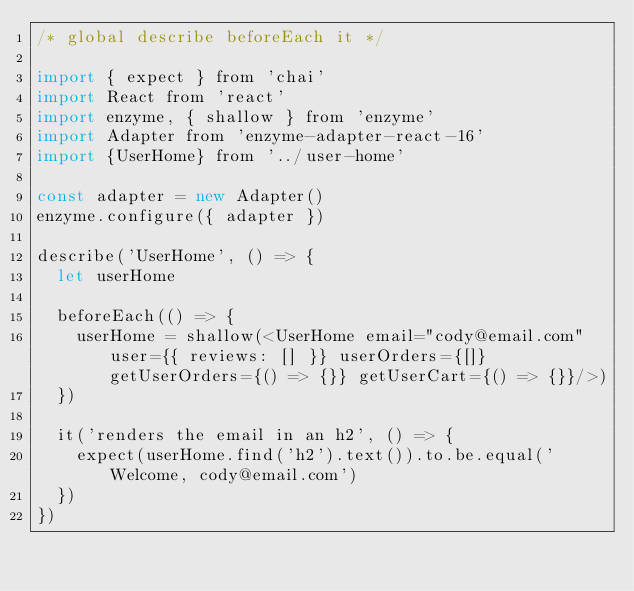Convert code to text. <code><loc_0><loc_0><loc_500><loc_500><_JavaScript_>/* global describe beforeEach it */

import { expect } from 'chai'
import React from 'react'
import enzyme, { shallow } from 'enzyme'
import Adapter from 'enzyme-adapter-react-16'
import {UserHome} from '../user-home'

const adapter = new Adapter()
enzyme.configure({ adapter })

describe('UserHome', () => {
  let userHome

  beforeEach(() => {
    userHome = shallow(<UserHome email="cody@email.com" user={{ reviews: [] }} userOrders={[]} getUserOrders={() => {}} getUserCart={() => {}}/>)
  })

  it('renders the email in an h2', () => {
    expect(userHome.find('h2').text()).to.be.equal('Welcome, cody@email.com')
  })
})
</code> 